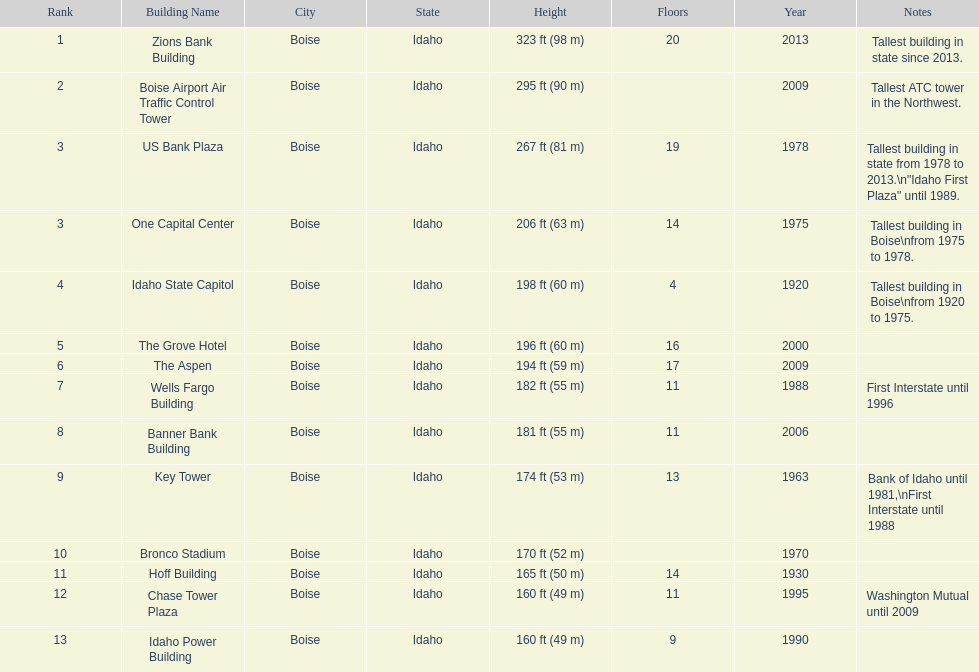What is the number of floors of the oldest building? 4. Parse the full table. {'header': ['Rank', 'Building Name', 'City', 'State', 'Height', 'Floors', 'Year', 'Notes'], 'rows': [['1', 'Zions Bank Building', 'Boise', 'Idaho', '323\xa0ft (98\xa0m)', '20', '2013', 'Tallest building in state since 2013.'], ['2', 'Boise Airport Air Traffic Control Tower', 'Boise', 'Idaho', '295\xa0ft (90\xa0m)', '', '2009', 'Tallest ATC tower in the Northwest.'], ['3', 'US Bank Plaza', 'Boise', 'Idaho', '267\xa0ft (81\xa0m)', '19', '1978', 'Tallest building in state from 1978 to 2013.\\n"Idaho First Plaza" until 1989.'], ['3', 'One Capital Center', 'Boise', 'Idaho', '206\xa0ft (63\xa0m)', '14', '1975', 'Tallest building in Boise\\nfrom 1975 to 1978.'], ['4', 'Idaho State Capitol', 'Boise', 'Idaho', '198\xa0ft (60\xa0m)', '4', '1920', 'Tallest building in Boise\\nfrom 1920 to 1975.'], ['5', 'The Grove Hotel', 'Boise', 'Idaho', '196\xa0ft (60\xa0m)', '16', '2000', ''], ['6', 'The Aspen', 'Boise', 'Idaho', '194\xa0ft (59\xa0m)', '17', '2009', ''], ['7', 'Wells Fargo Building', 'Boise', 'Idaho', '182\xa0ft (55\xa0m)', '11', '1988', 'First Interstate until 1996'], ['8', 'Banner Bank Building', 'Boise', 'Idaho', '181\xa0ft (55\xa0m)', '11', '2006', ''], ['9', 'Key Tower', 'Boise', 'Idaho', '174\xa0ft (53\xa0m)', '13', '1963', 'Bank of Idaho until 1981,\\nFirst Interstate until 1988'], ['10', 'Bronco Stadium', 'Boise', 'Idaho', '170\xa0ft (52\xa0m)', '', '1970', ''], ['11', 'Hoff Building', 'Boise', 'Idaho', '165\xa0ft (50\xa0m)', '14', '1930', ''], ['12', 'Chase Tower Plaza', 'Boise', 'Idaho', '160\xa0ft (49\xa0m)', '11', '1995', 'Washington Mutual until 2009'], ['13', 'Idaho Power Building', 'Boise', 'Idaho', '160\xa0ft (49\xa0m)', '9', '1990', '']]} 